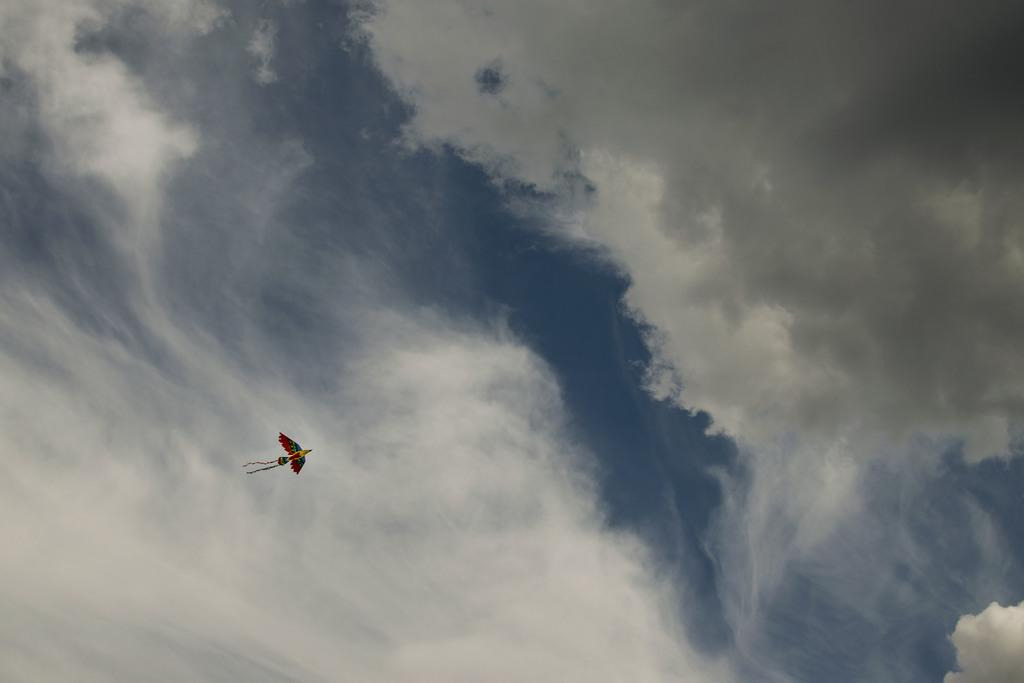What object is the main focus of the image? There is a kite in the image. Can you describe the appearance of the kite? The kite has multiple colors. What can be seen in the background of the image? The sky is blue and white in the image. What type of headwear is the kite wearing in the image? The kite is not a living being and therefore cannot wear headwear. 